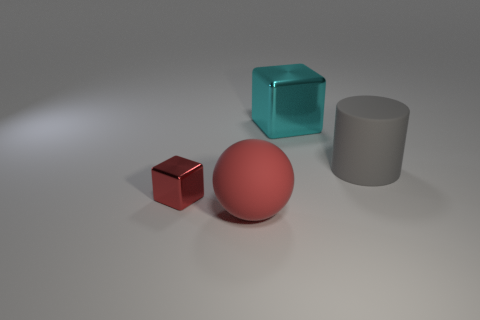Is there any other thing of the same color as the large rubber ball?
Your response must be concise. Yes. What shape is the big matte thing that is the same color as the small metal object?
Give a very brief answer. Sphere. There is a large thing left of the large cyan thing; is its color the same as the tiny metal thing?
Make the answer very short. Yes. What is the color of the thing that is in front of the tiny red object?
Offer a terse response. Red. What is the shape of the matte thing that is right of the block behind the gray object?
Provide a short and direct response. Cylinder. Do the ball and the small thing have the same color?
Offer a terse response. Yes. What number of spheres are rubber objects or large cyan shiny things?
Your response must be concise. 1. There is a object that is behind the large red sphere and left of the big block; what material is it?
Offer a very short reply. Metal. What number of big metallic cubes are to the right of the large red ball?
Ensure brevity in your answer.  1. Do the large thing left of the big cyan block and the big gray thing that is to the right of the red matte thing have the same material?
Your answer should be compact. Yes. 